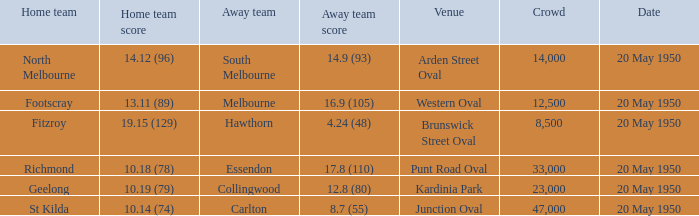Would you be able to parse every entry in this table? {'header': ['Home team', 'Home team score', 'Away team', 'Away team score', 'Venue', 'Crowd', 'Date'], 'rows': [['North Melbourne', '14.12 (96)', 'South Melbourne', '14.9 (93)', 'Arden Street Oval', '14,000', '20 May 1950'], ['Footscray', '13.11 (89)', 'Melbourne', '16.9 (105)', 'Western Oval', '12,500', '20 May 1950'], ['Fitzroy', '19.15 (129)', 'Hawthorn', '4.24 (48)', 'Brunswick Street Oval', '8,500', '20 May 1950'], ['Richmond', '10.18 (78)', 'Essendon', '17.8 (110)', 'Punt Road Oval', '33,000', '20 May 1950'], ['Geelong', '10.19 (79)', 'Collingwood', '12.8 (80)', 'Kardinia Park', '23,000', '20 May 1950'], ['St Kilda', '10.14 (74)', 'Carlton', '8.7 (55)', 'Junction Oval', '47,000', '20 May 1950']]} At which venue did the away team achieve a score of 1 Arden Street Oval. 